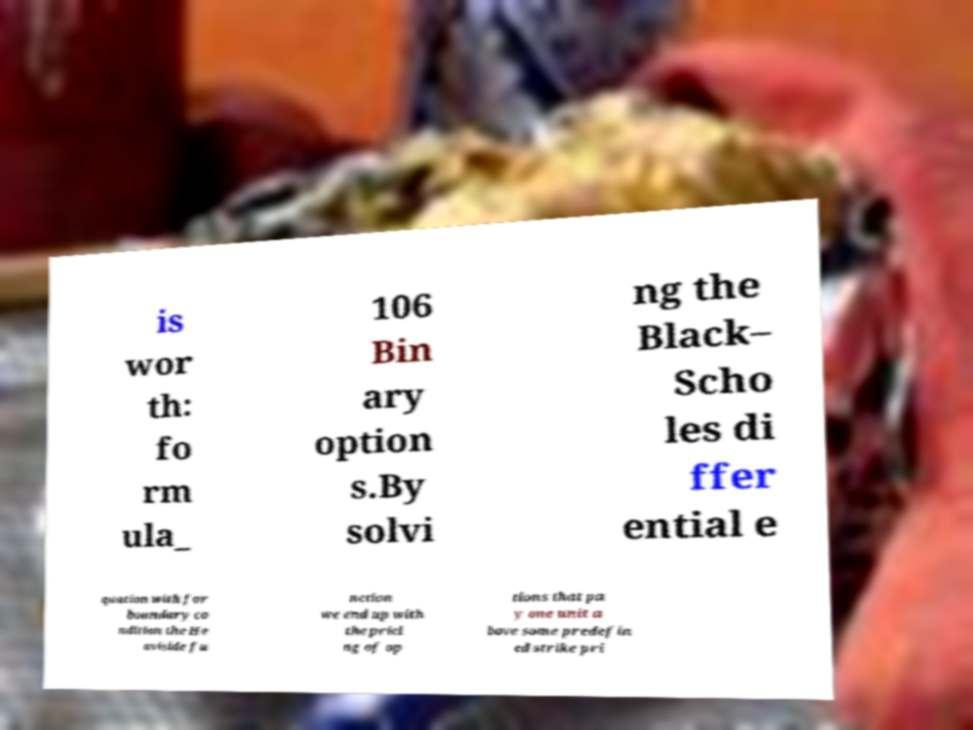Please identify and transcribe the text found in this image. is wor th: fo rm ula_ 106 Bin ary option s.By solvi ng the Black– Scho les di ffer ential e quation with for boundary co ndition the He aviside fu nction we end up with the prici ng of op tions that pa y one unit a bove some predefin ed strike pri 